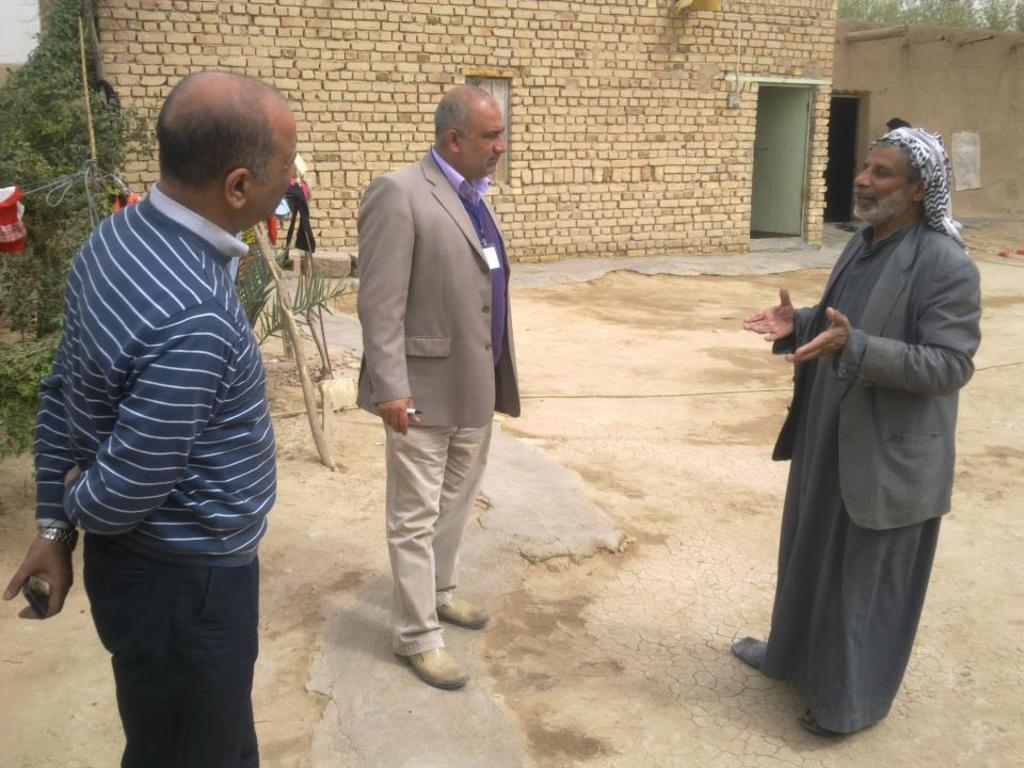What is happening in the image? There are people standing in the image. Where are the people standing? The people are standing on land. What can be seen in the background of the image? There are trees and houses in the background of the image. How many boys are present in the image? The provided facts do not mention any boys in the image, so we cannot determine the number of boys present. 